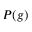Convert formula to latex. <formula><loc_0><loc_0><loc_500><loc_500>P ( g )</formula> 